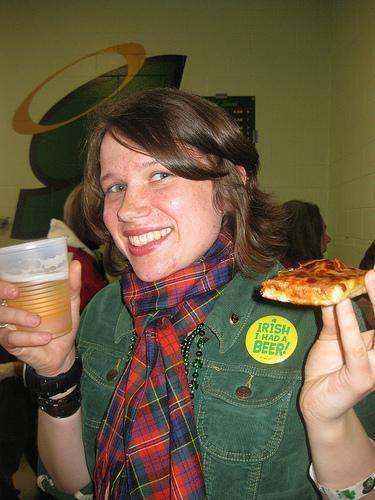How many hands are holding a drink?
Give a very brief answer. 1. 